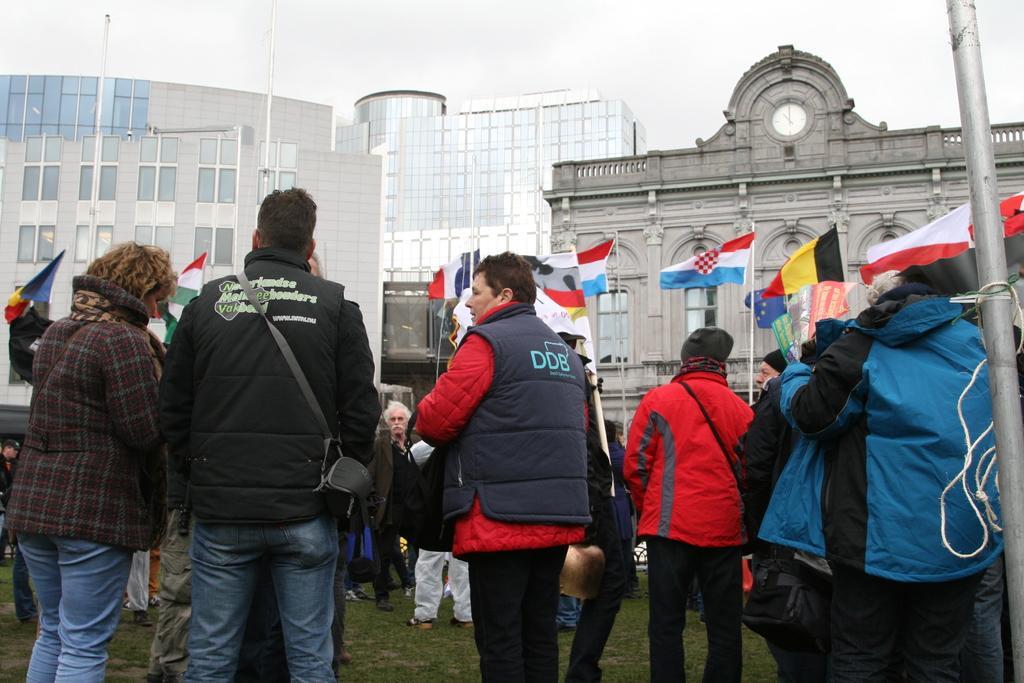Could you give a brief overview of what you see in this image? In this picture I can observe some people standing on the ground. Most of them are men. On the right side I can observe a pole. There are some flags in front of the people. In the background there are buildings and sky. 